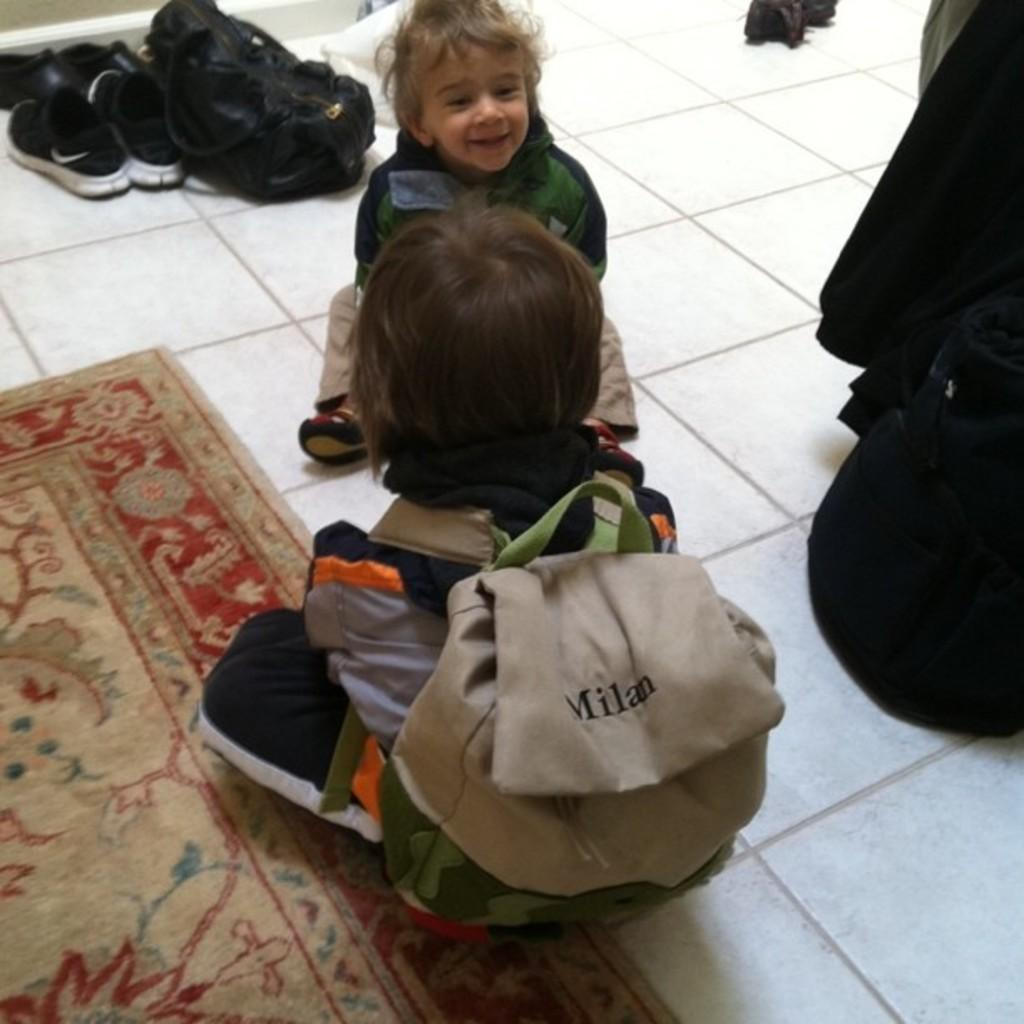<image>
Offer a succinct explanation of the picture presented. Two small children on the floor, one child has Milan printed on their book bag. 